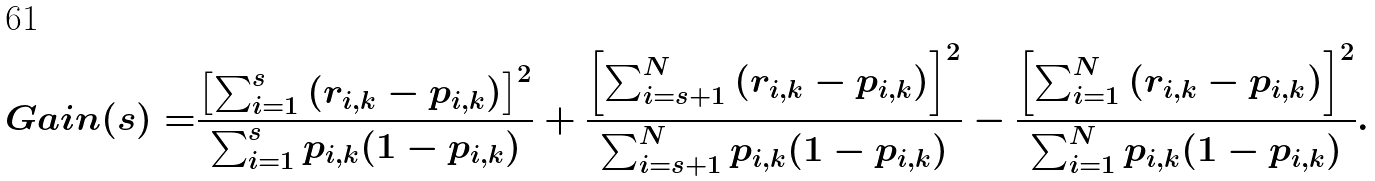<formula> <loc_0><loc_0><loc_500><loc_500>G a i n ( s ) = & \frac { \left [ \sum _ { i = 1 } ^ { s } \left ( r _ { i , k } - p _ { i , k } \right ) \right ] ^ { 2 } } { \sum _ { i = 1 } ^ { s } p _ { i , k } ( 1 - p _ { i , k } ) } + \frac { \left [ \sum _ { i = s + 1 } ^ { N } \left ( r _ { i , k } - p _ { i , k } \right ) \right ] ^ { 2 } } { \sum _ { i = s + 1 } ^ { N } p _ { i , k } ( 1 - p _ { i , k } ) } - \frac { \left [ \sum _ { i = 1 } ^ { N } \left ( r _ { i , k } - p _ { i , k } \right ) \right ] ^ { 2 } } { \sum _ { i = 1 } ^ { N } p _ { i , k } ( 1 - p _ { i , k } ) } .</formula> 